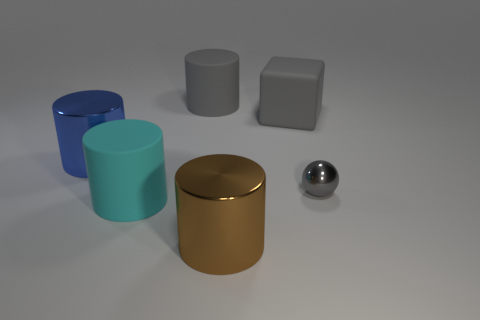Is the number of blue cylinders that are left of the big gray cube greater than the number of small balls left of the cyan object?
Ensure brevity in your answer.  Yes. What material is the cylinder that is the same color as the tiny thing?
Provide a succinct answer. Rubber. Is there any other thing that has the same shape as the tiny gray object?
Provide a succinct answer. No. There is a big thing that is both in front of the large gray rubber cube and behind the gray shiny sphere; what is it made of?
Offer a terse response. Metal. Are the tiny gray thing and the large blue object that is left of the tiny thing made of the same material?
Your response must be concise. Yes. Are there any other things that have the same size as the gray sphere?
Make the answer very short. No. What number of things are big blue shiny cubes or large things that are behind the sphere?
Ensure brevity in your answer.  3. There is a shiny cylinder on the right side of the blue cylinder; is it the same size as the gray object to the left of the brown cylinder?
Your answer should be very brief. Yes. How many other things are there of the same color as the large block?
Offer a very short reply. 2. Is the size of the gray rubber cylinder the same as the metal thing that is behind the tiny gray shiny ball?
Your response must be concise. Yes. 